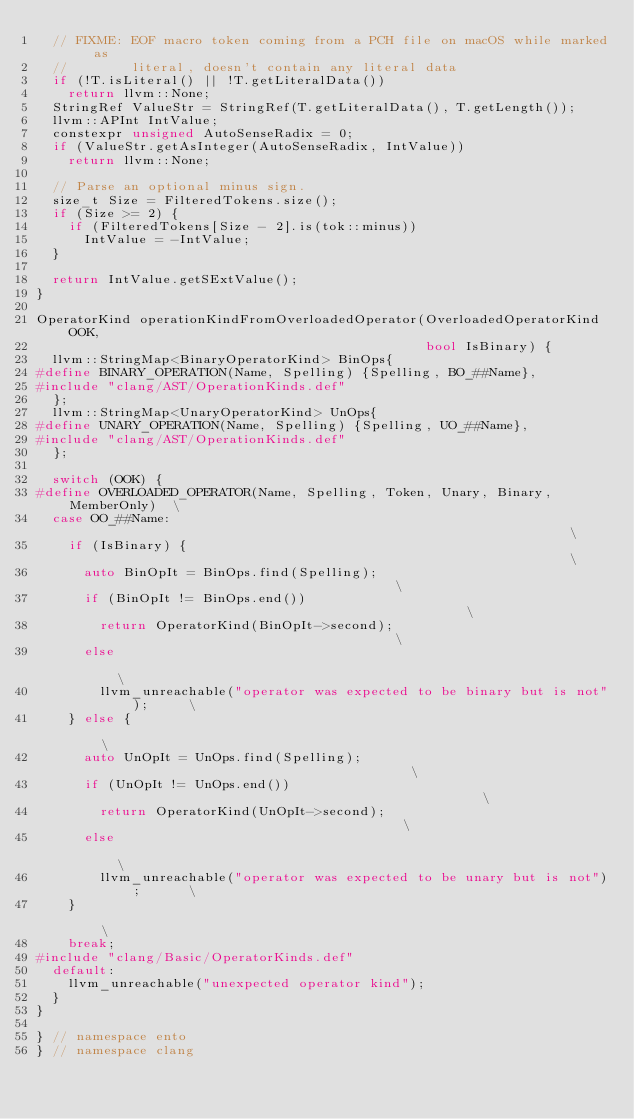<code> <loc_0><loc_0><loc_500><loc_500><_C++_>  // FIXME: EOF macro token coming from a PCH file on macOS while marked as
  //        literal, doesn't contain any literal data
  if (!T.isLiteral() || !T.getLiteralData())
    return llvm::None;
  StringRef ValueStr = StringRef(T.getLiteralData(), T.getLength());
  llvm::APInt IntValue;
  constexpr unsigned AutoSenseRadix = 0;
  if (ValueStr.getAsInteger(AutoSenseRadix, IntValue))
    return llvm::None;

  // Parse an optional minus sign.
  size_t Size = FilteredTokens.size();
  if (Size >= 2) {
    if (FilteredTokens[Size - 2].is(tok::minus))
      IntValue = -IntValue;
  }

  return IntValue.getSExtValue();
}

OperatorKind operationKindFromOverloadedOperator(OverloadedOperatorKind OOK,
                                                 bool IsBinary) {
  llvm::StringMap<BinaryOperatorKind> BinOps{
#define BINARY_OPERATION(Name, Spelling) {Spelling, BO_##Name},
#include "clang/AST/OperationKinds.def"
  };
  llvm::StringMap<UnaryOperatorKind> UnOps{
#define UNARY_OPERATION(Name, Spelling) {Spelling, UO_##Name},
#include "clang/AST/OperationKinds.def"
  };

  switch (OOK) {
#define OVERLOADED_OPERATOR(Name, Spelling, Token, Unary, Binary, MemberOnly)  \
  case OO_##Name:                                                              \
    if (IsBinary) {                                                            \
      auto BinOpIt = BinOps.find(Spelling);                                    \
      if (BinOpIt != BinOps.end())                                             \
        return OperatorKind(BinOpIt->second);                                  \
      else                                                                     \
        llvm_unreachable("operator was expected to be binary but is not");     \
    } else {                                                                   \
      auto UnOpIt = UnOps.find(Spelling);                                      \
      if (UnOpIt != UnOps.end())                                               \
        return OperatorKind(UnOpIt->second);                                   \
      else                                                                     \
        llvm_unreachable("operator was expected to be unary but is not");      \
    }                                                                          \
    break;
#include "clang/Basic/OperatorKinds.def"
  default:
    llvm_unreachable("unexpected operator kind");
  }
}

} // namespace ento
} // namespace clang
</code> 